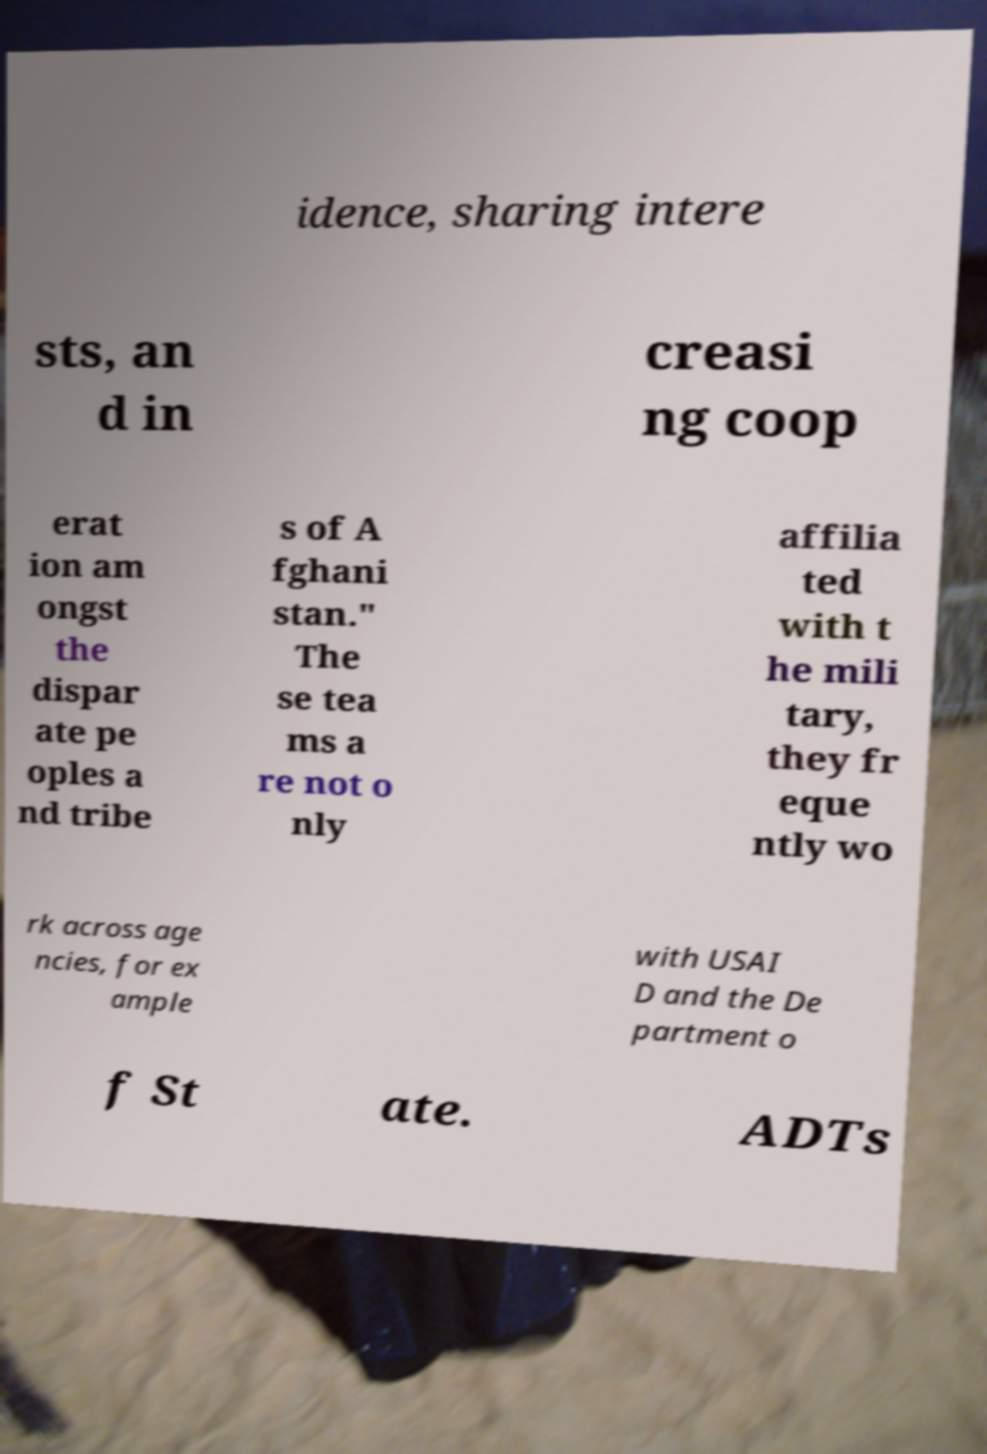Please identify and transcribe the text found in this image. idence, sharing intere sts, an d in creasi ng coop erat ion am ongst the dispar ate pe oples a nd tribe s of A fghani stan." The se tea ms a re not o nly affilia ted with t he mili tary, they fr eque ntly wo rk across age ncies, for ex ample with USAI D and the De partment o f St ate. ADTs 